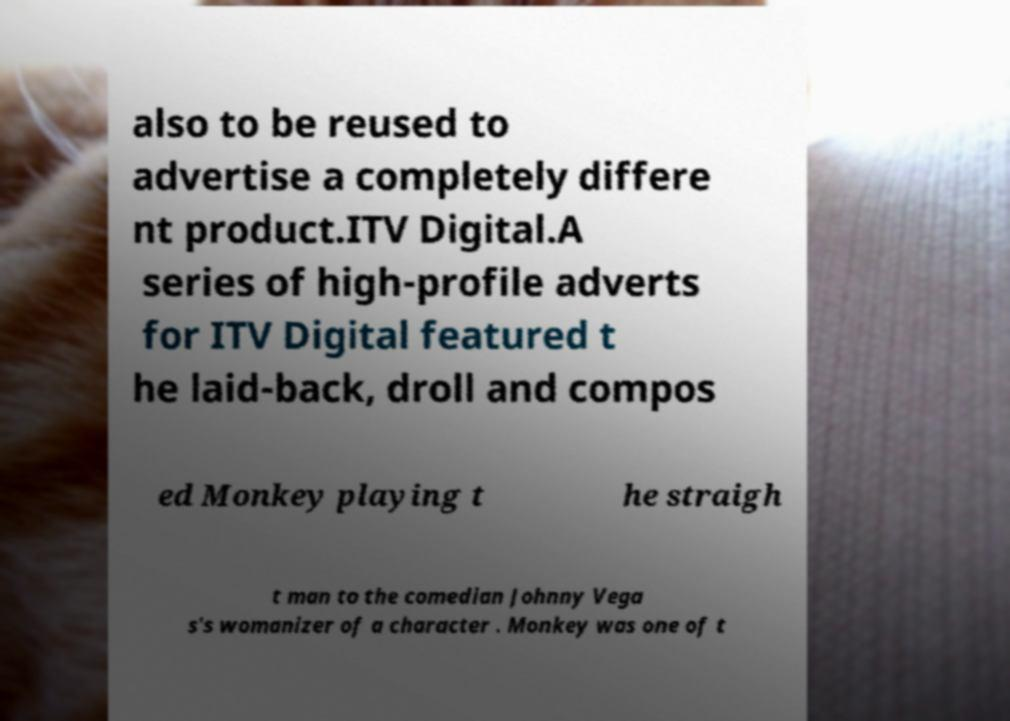There's text embedded in this image that I need extracted. Can you transcribe it verbatim? also to be reused to advertise a completely differe nt product.ITV Digital.A series of high-profile adverts for ITV Digital featured t he laid-back, droll and compos ed Monkey playing t he straigh t man to the comedian Johnny Vega s's womanizer of a character . Monkey was one of t 